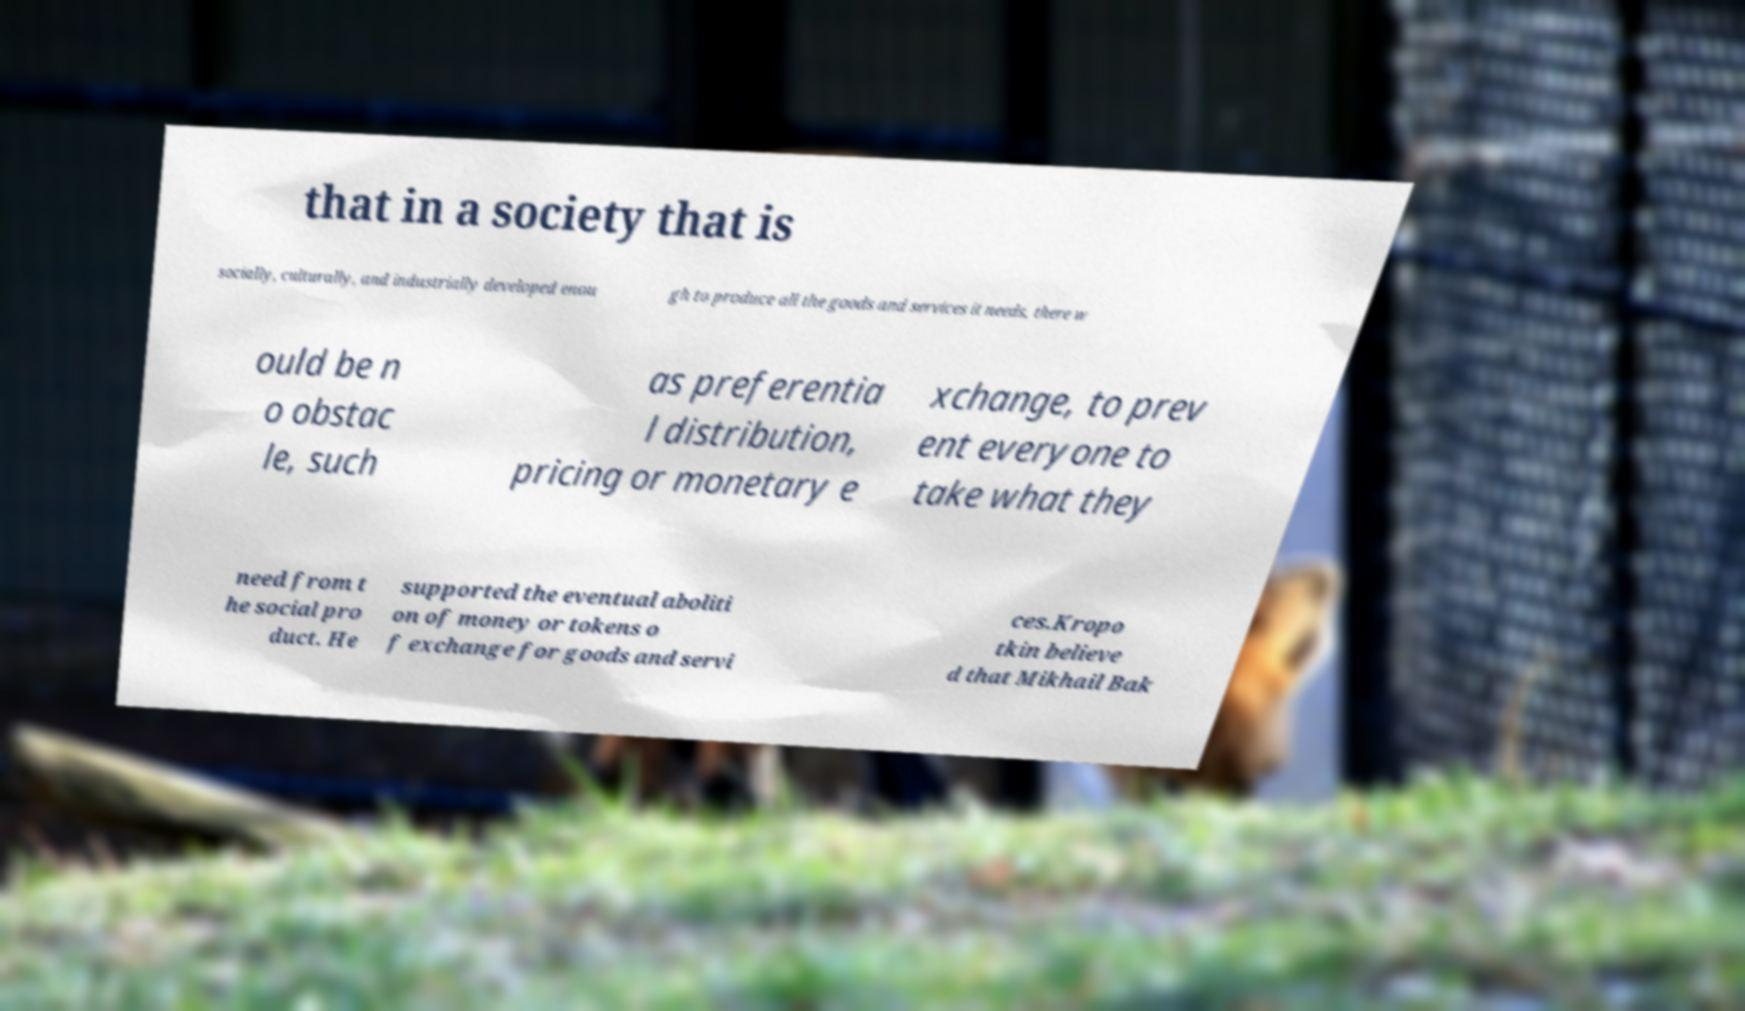Please read and relay the text visible in this image. What does it say? that in a society that is socially, culturally, and industrially developed enou gh to produce all the goods and services it needs, there w ould be n o obstac le, such as preferentia l distribution, pricing or monetary e xchange, to prev ent everyone to take what they need from t he social pro duct. He supported the eventual aboliti on of money or tokens o f exchange for goods and servi ces.Kropo tkin believe d that Mikhail Bak 